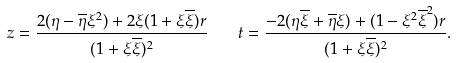<formula> <loc_0><loc_0><loc_500><loc_500>z = \frac { 2 ( \eta - \overline { \eta } \xi ^ { 2 } ) + 2 \xi ( 1 + \xi \overline { \xi } ) r } { ( 1 + \xi \overline { \xi } ) ^ { 2 } } \quad t = \frac { - 2 ( \eta \overline { \xi } + \overline { \eta } \xi ) + ( 1 - \xi ^ { 2 } \overline { \xi } ^ { 2 } ) r } { ( 1 + \xi \overline { \xi } ) ^ { 2 } } .</formula> 